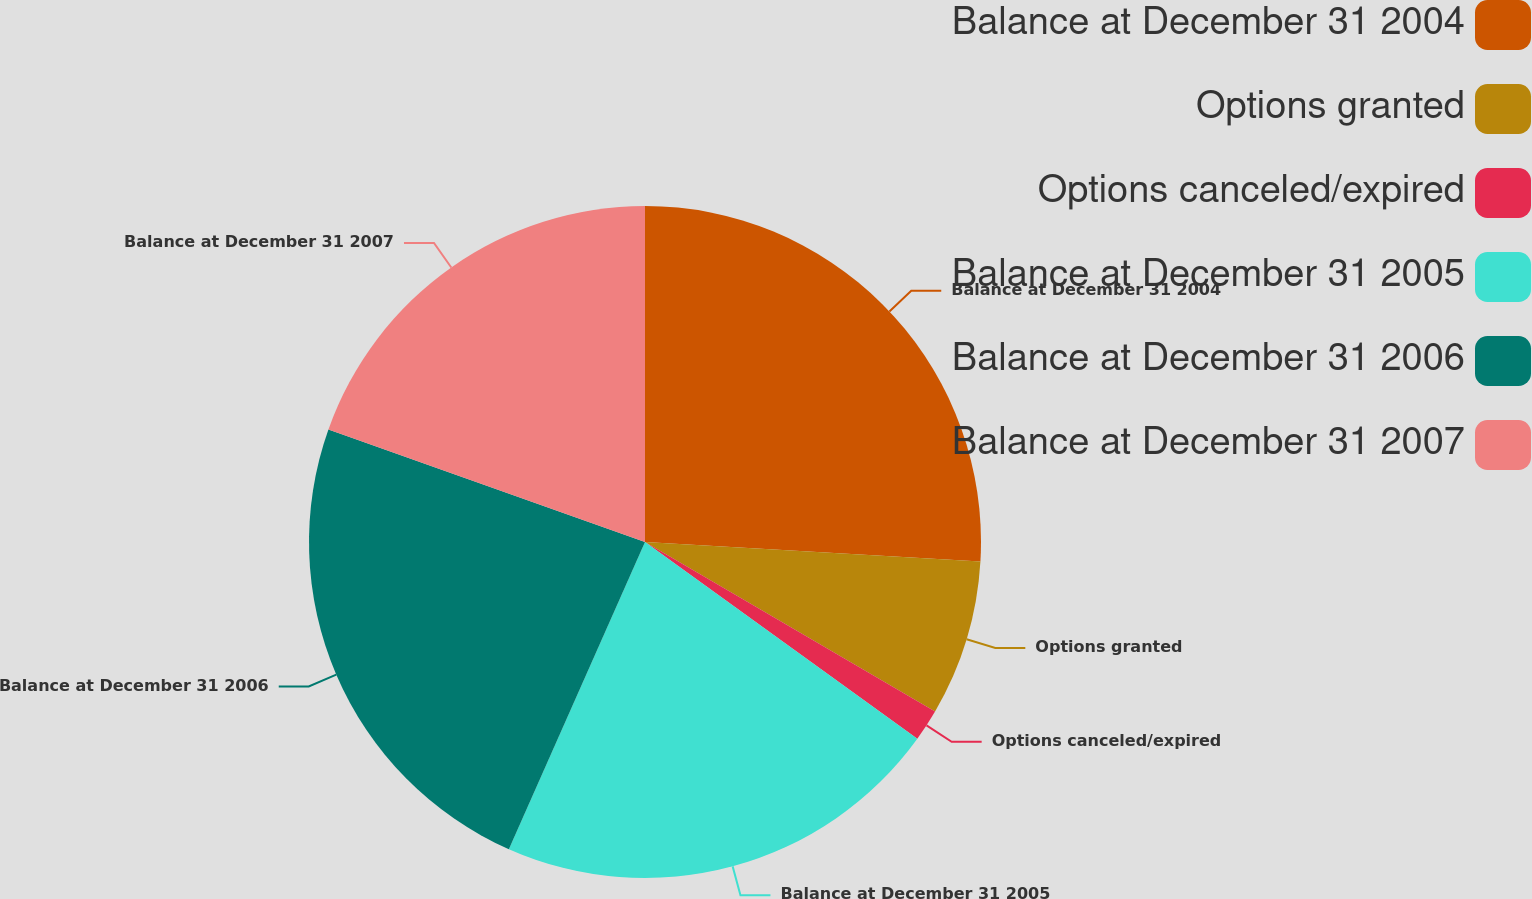Convert chart. <chart><loc_0><loc_0><loc_500><loc_500><pie_chart><fcel>Balance at December 31 2004<fcel>Options granted<fcel>Options canceled/expired<fcel>Balance at December 31 2005<fcel>Balance at December 31 2006<fcel>Balance at December 31 2007<nl><fcel>25.93%<fcel>7.49%<fcel>1.54%<fcel>21.68%<fcel>23.8%<fcel>19.56%<nl></chart> 